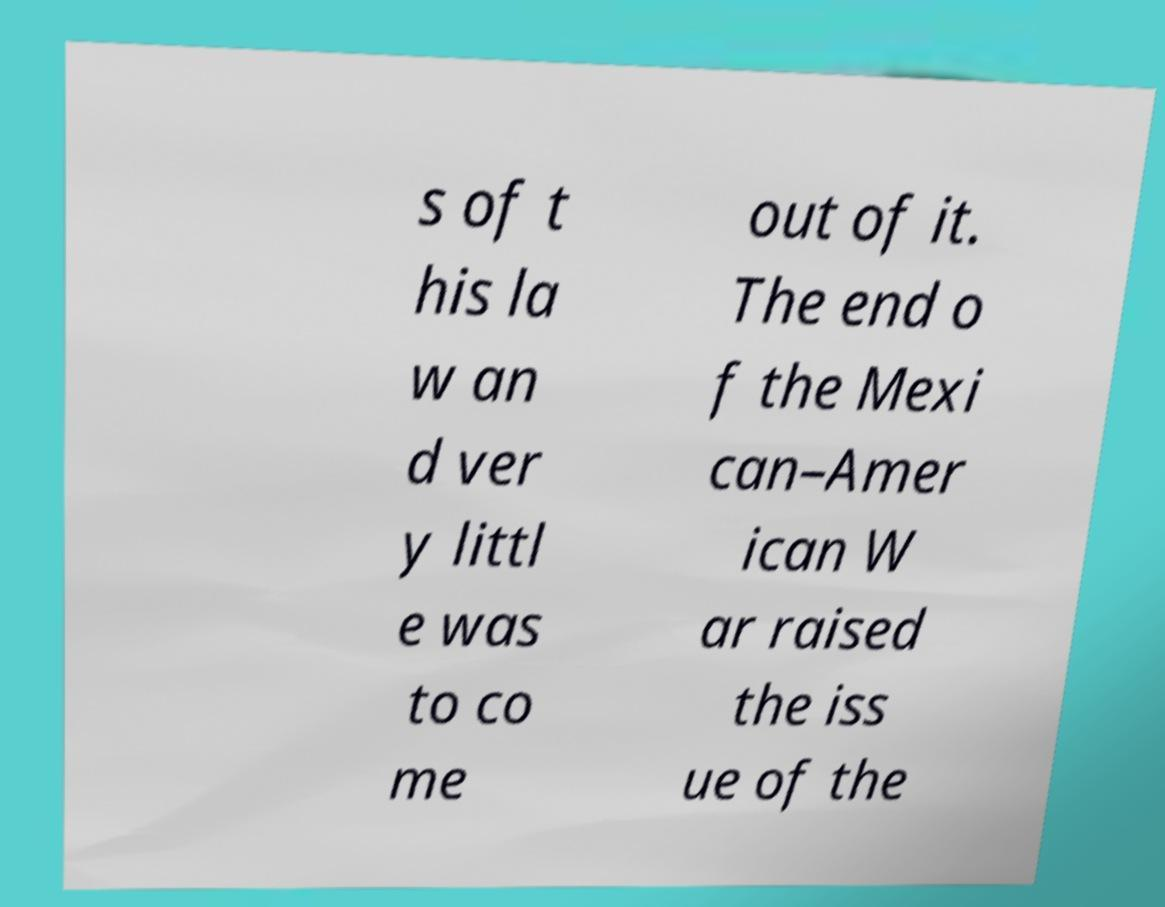What messages or text are displayed in this image? I need them in a readable, typed format. s of t his la w an d ver y littl e was to co me out of it. The end o f the Mexi can–Amer ican W ar raised the iss ue of the 